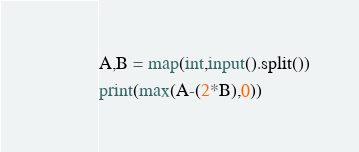<code> <loc_0><loc_0><loc_500><loc_500><_Python_>A,B = map(int,input().split())
print(max(A-(2*B),0))</code> 